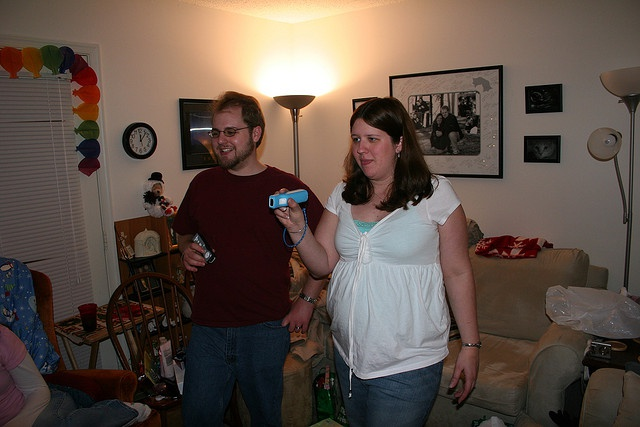Describe the objects in this image and their specific colors. I can see people in black, darkgray, and brown tones, people in black, maroon, and brown tones, couch in black, maroon, and navy tones, chair in black, maroon, and gray tones, and people in black and gray tones in this image. 